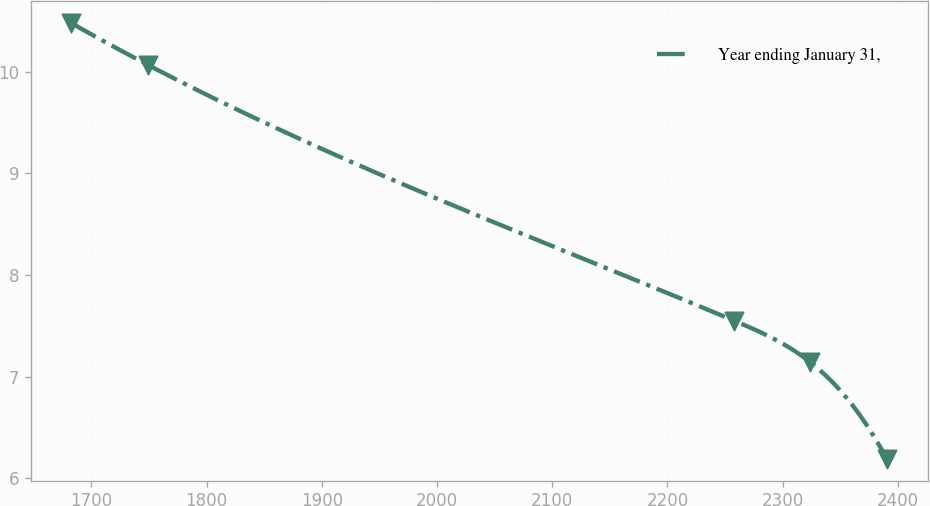Convert chart to OTSL. <chart><loc_0><loc_0><loc_500><loc_500><line_chart><ecel><fcel>Year ending January 31,<nl><fcel>1682.59<fcel>10.48<nl><fcel>1748.84<fcel>10.07<nl><fcel>2257.96<fcel>7.55<nl><fcel>2324.21<fcel>7.14<nl><fcel>2390.46<fcel>6.19<nl></chart> 